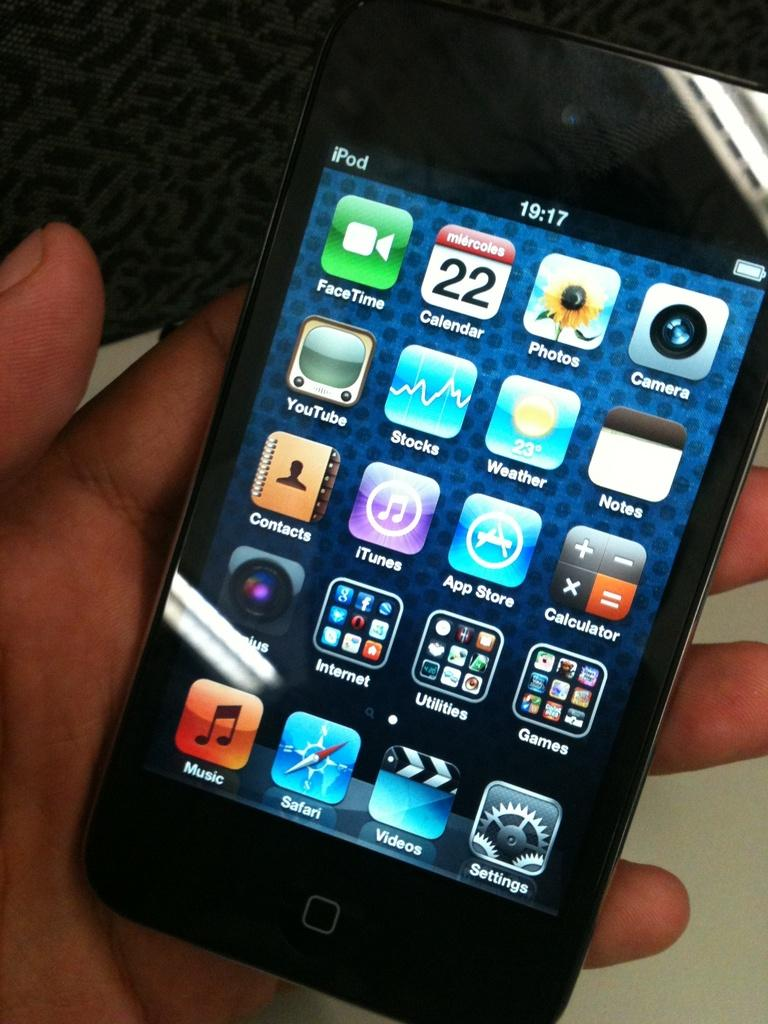<image>
Render a clear and concise summary of the photo. A black iPod displays many applications including FaceTime, Calendar, Photos, Camera, YouTube, Stocks, Weather and others. 